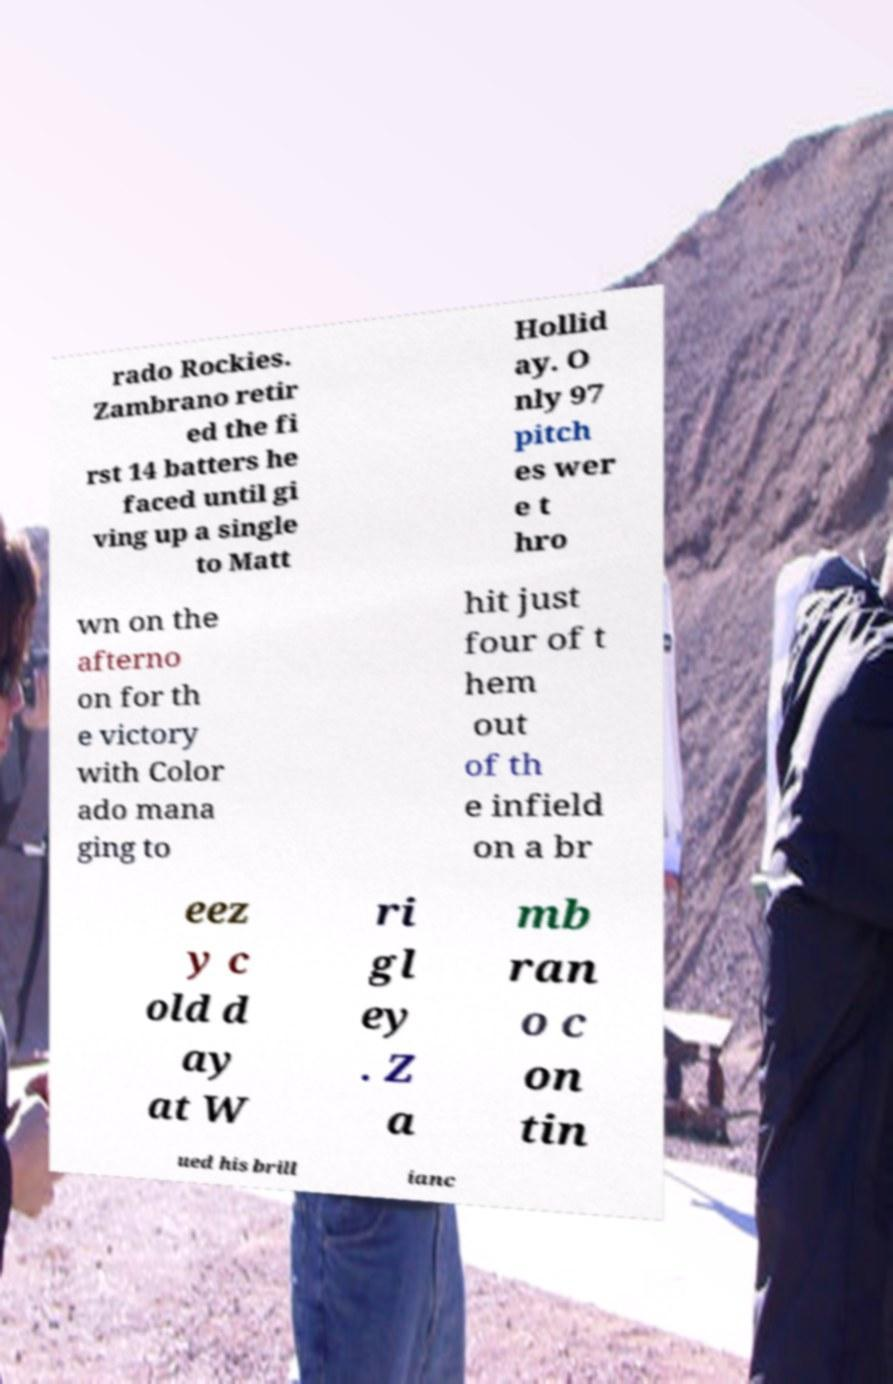What messages or text are displayed in this image? I need them in a readable, typed format. rado Rockies. Zambrano retir ed the fi rst 14 batters he faced until gi ving up a single to Matt Hollid ay. O nly 97 pitch es wer e t hro wn on the afterno on for th e victory with Color ado mana ging to hit just four of t hem out of th e infield on a br eez y c old d ay at W ri gl ey . Z a mb ran o c on tin ued his brill ianc 